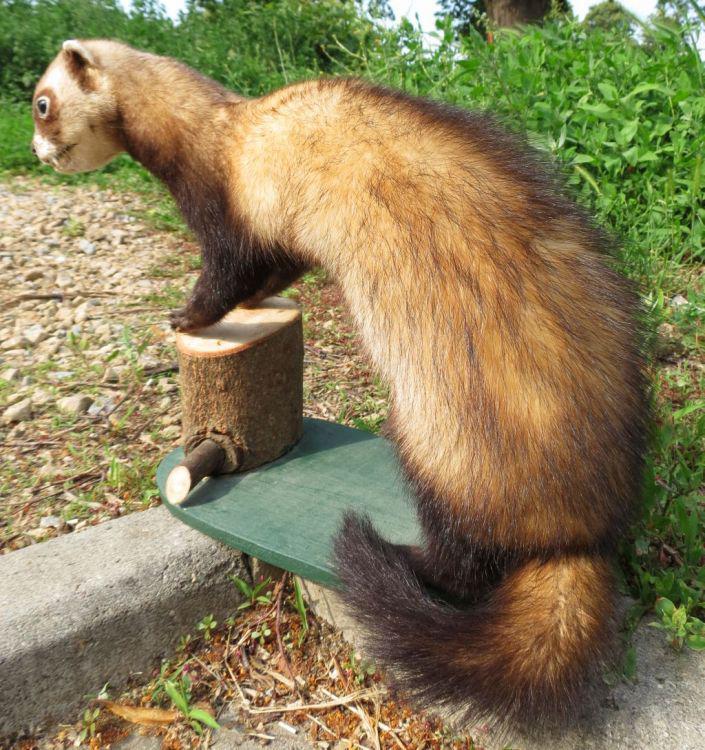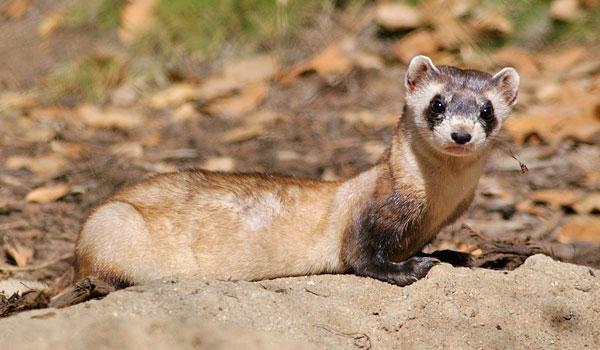The first image is the image on the left, the second image is the image on the right. For the images displayed, is the sentence "In one of the images, the weasel's body is turned to the right, and in the other, it's turned to the left." factually correct? Answer yes or no. Yes. 